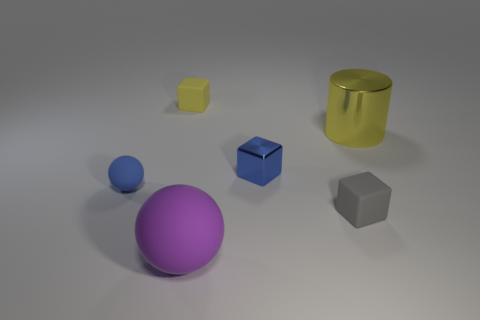Add 4 tiny purple rubber cylinders. How many objects exist? 10 Subtract all gray rubber cubes. How many cubes are left? 2 Subtract all cylinders. How many objects are left? 5 Add 6 small blue metallic blocks. How many small blue metallic blocks exist? 7 Subtract all blue balls. How many balls are left? 1 Subtract 0 blue cylinders. How many objects are left? 6 Subtract 1 cylinders. How many cylinders are left? 0 Subtract all green blocks. Subtract all purple cylinders. How many blocks are left? 3 Subtract all purple cylinders. How many cyan balls are left? 0 Subtract all small balls. Subtract all yellow shiny objects. How many objects are left? 4 